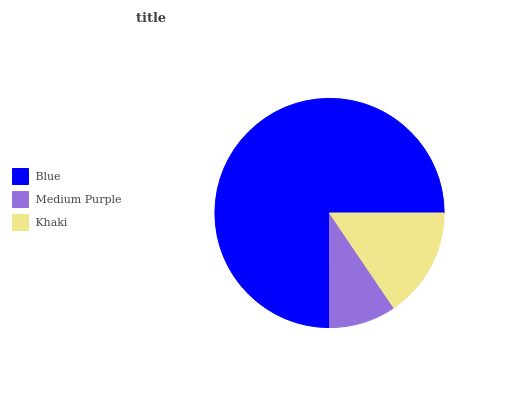Is Medium Purple the minimum?
Answer yes or no. Yes. Is Blue the maximum?
Answer yes or no. Yes. Is Khaki the minimum?
Answer yes or no. No. Is Khaki the maximum?
Answer yes or no. No. Is Khaki greater than Medium Purple?
Answer yes or no. Yes. Is Medium Purple less than Khaki?
Answer yes or no. Yes. Is Medium Purple greater than Khaki?
Answer yes or no. No. Is Khaki less than Medium Purple?
Answer yes or no. No. Is Khaki the high median?
Answer yes or no. Yes. Is Khaki the low median?
Answer yes or no. Yes. Is Blue the high median?
Answer yes or no. No. Is Medium Purple the low median?
Answer yes or no. No. 